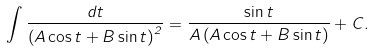Convert formula to latex. <formula><loc_0><loc_0><loc_500><loc_500>\int \frac { d t } { \left ( A \cos t + B \sin t \right ) ^ { 2 } } = \frac { \sin t } { A \left ( A \cos t + B \sin t \right ) } + C .</formula> 